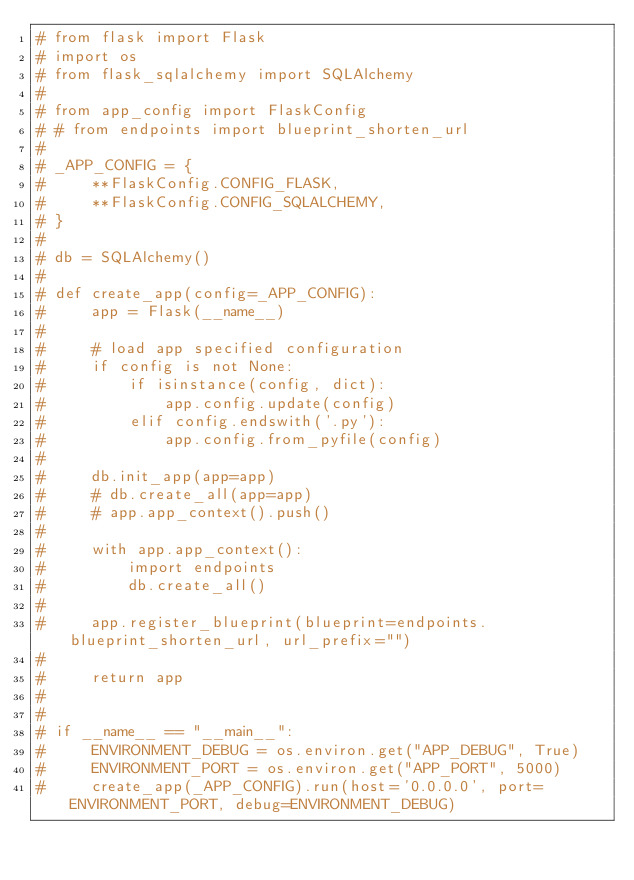Convert code to text. <code><loc_0><loc_0><loc_500><loc_500><_Python_># from flask import Flask
# import os
# from flask_sqlalchemy import SQLAlchemy
#
# from app_config import FlaskConfig
# # from endpoints import blueprint_shorten_url
#
# _APP_CONFIG = {
#     **FlaskConfig.CONFIG_FLASK,
#     **FlaskConfig.CONFIG_SQLALCHEMY,
# }
#
# db = SQLAlchemy()
#
# def create_app(config=_APP_CONFIG):
#     app = Flask(__name__)
#
#     # load app specified configuration
#     if config is not None:
#         if isinstance(config, dict):
#             app.config.update(config)
#         elif config.endswith('.py'):
#             app.config.from_pyfile(config)
#
#     db.init_app(app=app)
#     # db.create_all(app=app)
#     # app.app_context().push()
#
#     with app.app_context():
#         import endpoints
#         db.create_all()
#
#     app.register_blueprint(blueprint=endpoints.blueprint_shorten_url, url_prefix="")
#
#     return app
#
#
# if __name__ == "__main__":
#     ENVIRONMENT_DEBUG = os.environ.get("APP_DEBUG", True)
#     ENVIRONMENT_PORT = os.environ.get("APP_PORT", 5000)
#     create_app(_APP_CONFIG).run(host='0.0.0.0', port=ENVIRONMENT_PORT, debug=ENVIRONMENT_DEBUG)</code> 